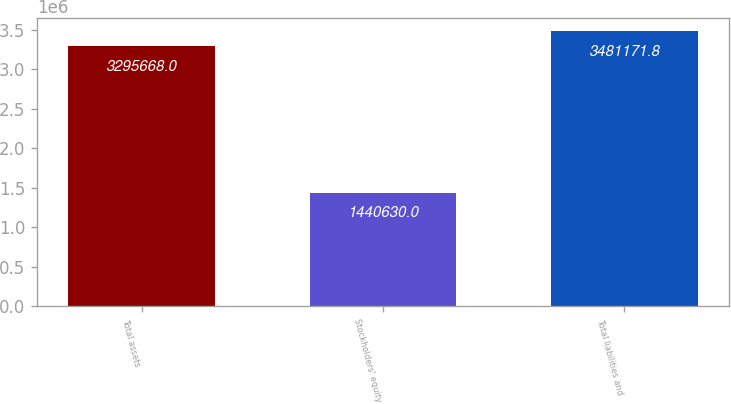Convert chart to OTSL. <chart><loc_0><loc_0><loc_500><loc_500><bar_chart><fcel>Total assets<fcel>Stockholders' equity<fcel>Total liabilities and<nl><fcel>3.29567e+06<fcel>1.44063e+06<fcel>3.48117e+06<nl></chart> 